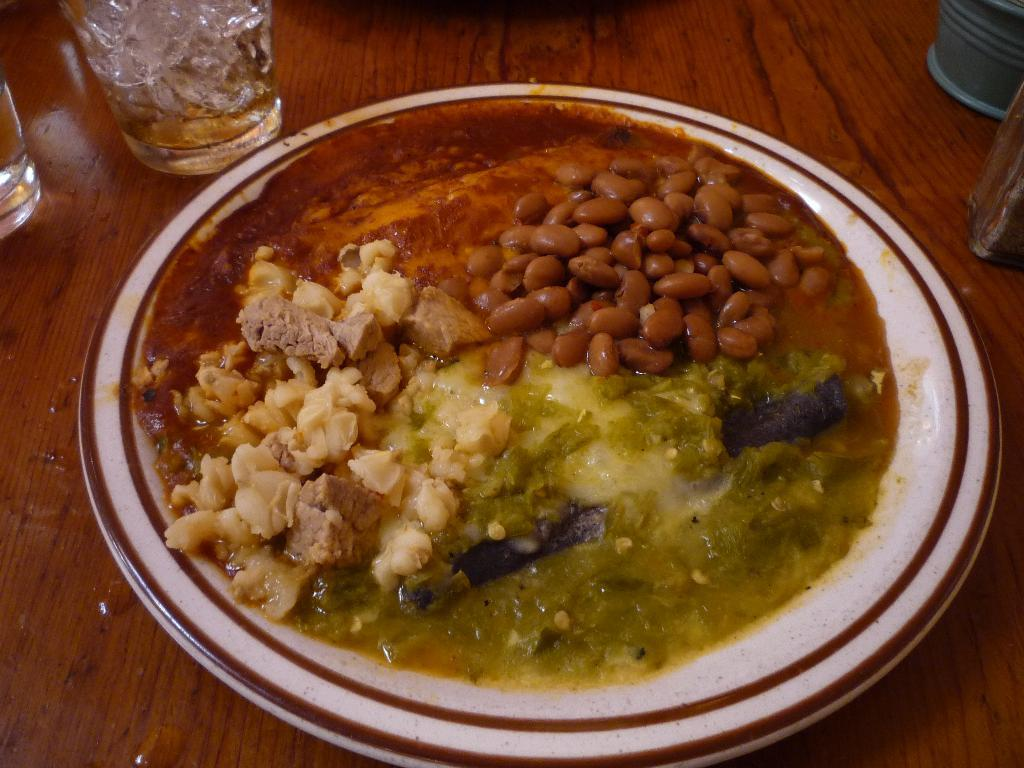What is on the plate that is visible in the image? There is a plate with food items in the image. What color is the plate? The plate is white in color. What else can be seen on the wooden surface in the image? There are glasses on a wooden surface in the image. How does the mother interact with the pan in the image? There is no pan or mother present in the image. 